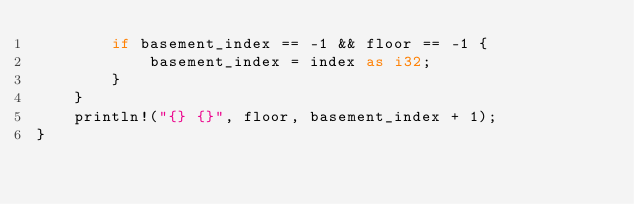<code> <loc_0><loc_0><loc_500><loc_500><_Rust_>        if basement_index == -1 && floor == -1 {
            basement_index = index as i32;
        }
    }
    println!("{} {}", floor, basement_index + 1);
}
</code> 